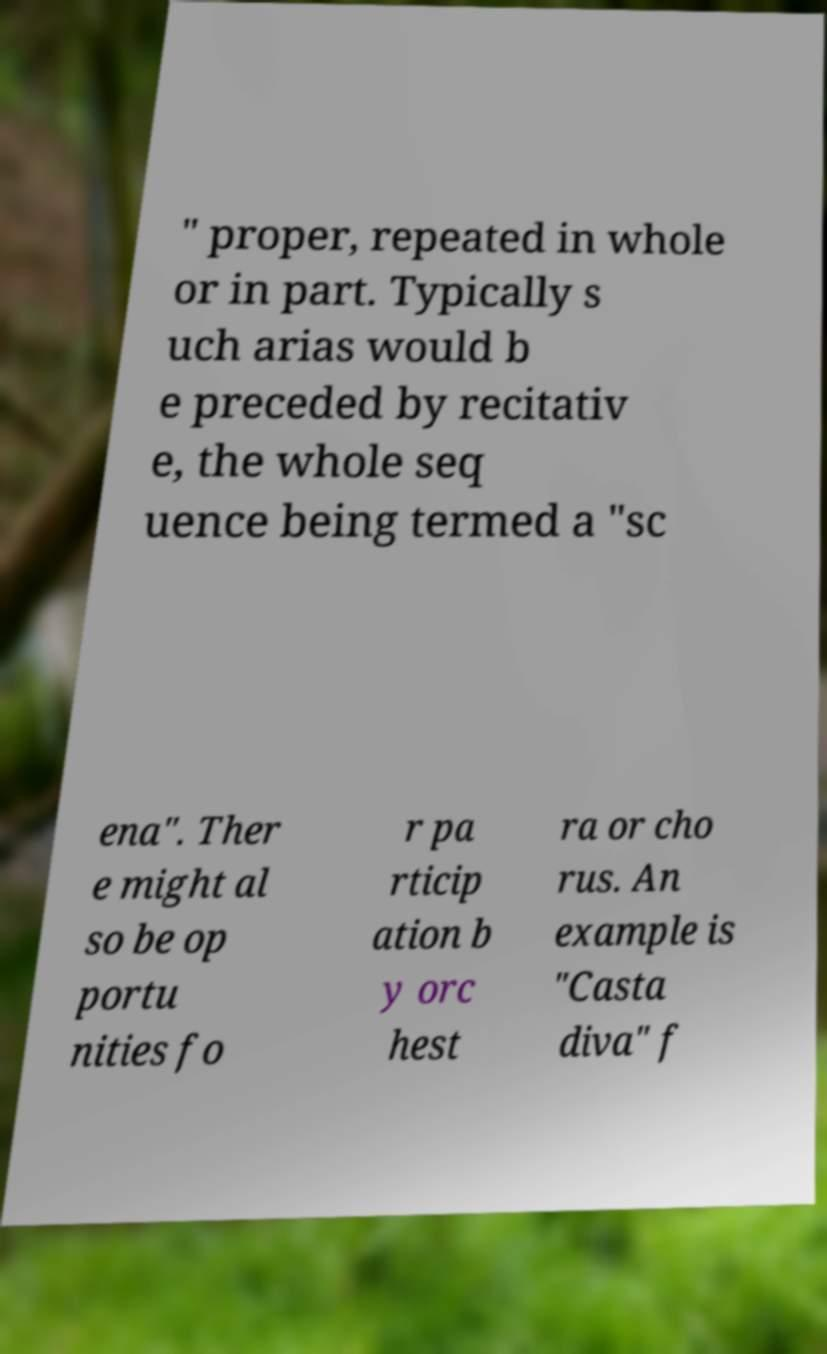I need the written content from this picture converted into text. Can you do that? " proper, repeated in whole or in part. Typically s uch arias would b e preceded by recitativ e, the whole seq uence being termed a "sc ena". Ther e might al so be op portu nities fo r pa rticip ation b y orc hest ra or cho rus. An example is "Casta diva" f 